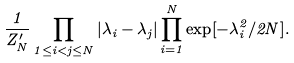Convert formula to latex. <formula><loc_0><loc_0><loc_500><loc_500>\frac { 1 } { Z ^ { \prime } _ { N } } \prod _ { 1 \leq i < j \leq N } | \lambda _ { i } - \lambda _ { j } | \prod _ { i = 1 } ^ { N } \exp [ - \lambda _ { i } ^ { 2 } / 2 N ] .</formula> 